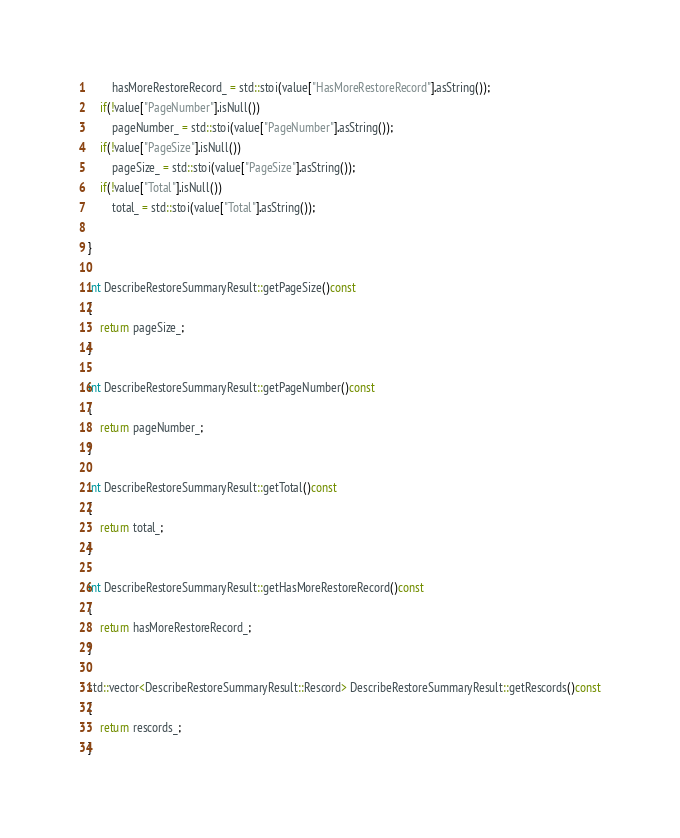<code> <loc_0><loc_0><loc_500><loc_500><_C++_>		hasMoreRestoreRecord_ = std::stoi(value["HasMoreRestoreRecord"].asString());
	if(!value["PageNumber"].isNull())
		pageNumber_ = std::stoi(value["PageNumber"].asString());
	if(!value["PageSize"].isNull())
		pageSize_ = std::stoi(value["PageSize"].asString());
	if(!value["Total"].isNull())
		total_ = std::stoi(value["Total"].asString());

}

int DescribeRestoreSummaryResult::getPageSize()const
{
	return pageSize_;
}

int DescribeRestoreSummaryResult::getPageNumber()const
{
	return pageNumber_;
}

int DescribeRestoreSummaryResult::getTotal()const
{
	return total_;
}

int DescribeRestoreSummaryResult::getHasMoreRestoreRecord()const
{
	return hasMoreRestoreRecord_;
}

std::vector<DescribeRestoreSummaryResult::Rescord> DescribeRestoreSummaryResult::getRescords()const
{
	return rescords_;
}

</code> 